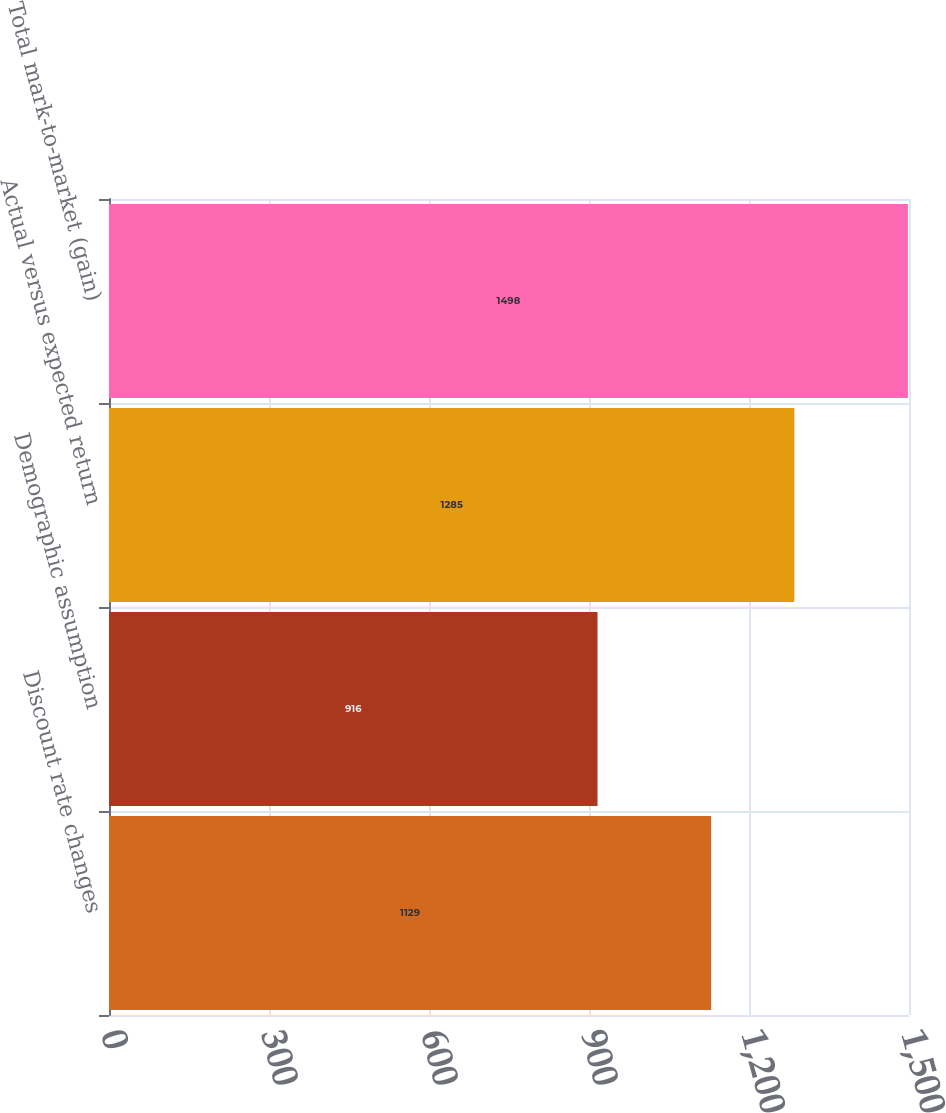Convert chart. <chart><loc_0><loc_0><loc_500><loc_500><bar_chart><fcel>Discount rate changes<fcel>Demographic assumption<fcel>Actual versus expected return<fcel>Total mark-to-market (gain)<nl><fcel>1129<fcel>916<fcel>1285<fcel>1498<nl></chart> 